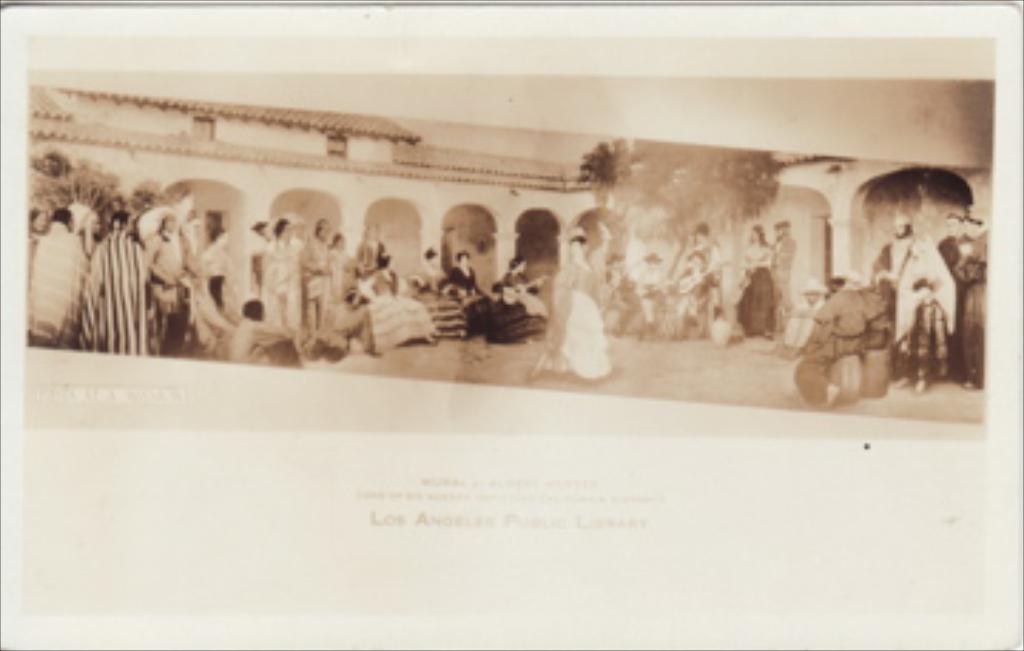In one or two sentences, can you explain what this image depicts? In this picture we can see an old photograph, here we can see people, building, trees and some text on it. 